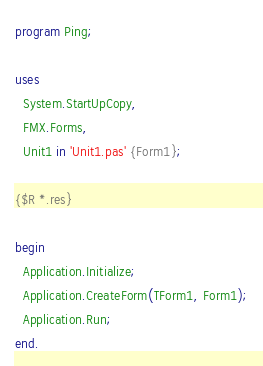<code> <loc_0><loc_0><loc_500><loc_500><_Pascal_>program Ping;

uses
  System.StartUpCopy,
  FMX.Forms,
  Unit1 in 'Unit1.pas' {Form1};

{$R *.res}

begin
  Application.Initialize;
  Application.CreateForm(TForm1, Form1);
  Application.Run;
end.
</code> 